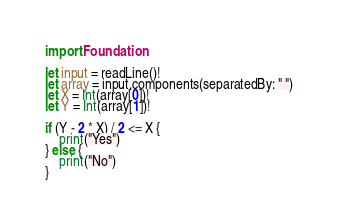Convert code to text. <code><loc_0><loc_0><loc_500><loc_500><_Swift_>import Foundation

let input = readLine()!
let array = input.components(separatedBy: " ")
let X = Int(array[0])!
let Y = Int(array[1])!

if (Y - 2 * X) / 2 <= X {
    print("Yes")
} else {
    print("No")
}</code> 